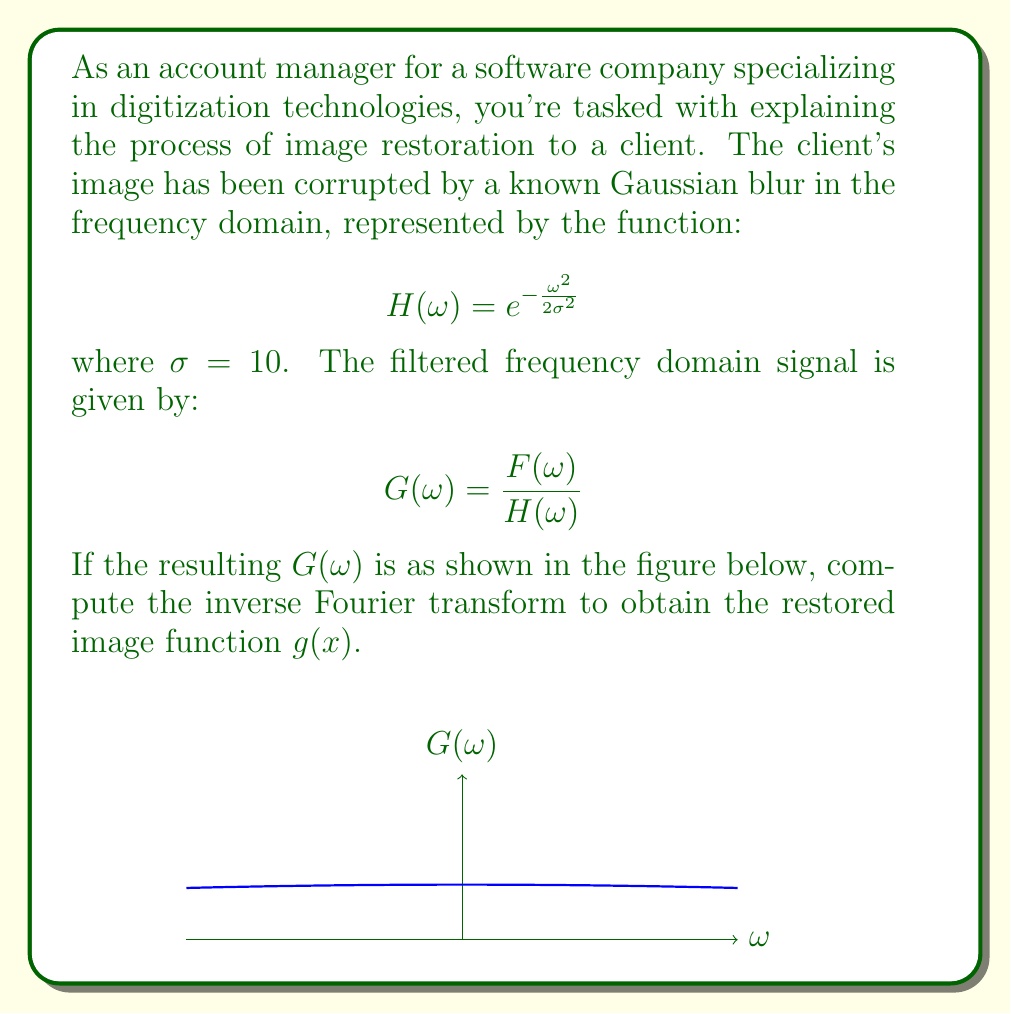What is the answer to this math problem? Let's approach this step-by-step:

1) The inverse Fourier transform is given by:

   $$g(x) = \frac{1}{2\pi} \int_{-\infty}^{\infty} G(\omega) e^{i\omega x} d\omega$$

2) From the graph, we can see that $G(\omega)$ resembles a Gaussian function. The general form of a Gaussian function in the frequency domain is:

   $$G(\omega) = Ae^{-\frac{\omega^2}{2b^2}}$$

   where $A$ is the amplitude and $b$ is related to the width of the Gaussian.

3) By examining the graph, we can determine that $A = 1$ and $b^2 = 200$. So:

   $$G(\omega) = e^{-\frac{\omega^2}{400}}$$

4) Substituting this into the inverse Fourier transform equation:

   $$g(x) = \frac{1}{2\pi} \int_{-\infty}^{\infty} e^{-\frac{\omega^2}{400}} e^{i\omega x} d\omega$$

5) This integral is a well-known Fourier transform pair. The result is:

   $$g(x) = \frac{\sqrt{400}}{2\pi} e^{-\frac{400x^2}{4}} = \frac{10}{\sqrt{\pi}} e^{-100x^2}$$

6) This is the restored image function in the spatial domain.
Answer: $g(x) = \frac{10}{\sqrt{\pi}} e^{-100x^2}$ 